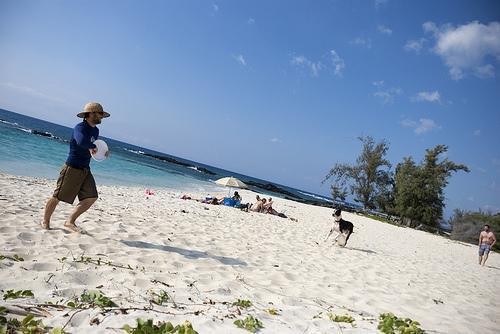How many dogs?
Give a very brief answer. 1. 